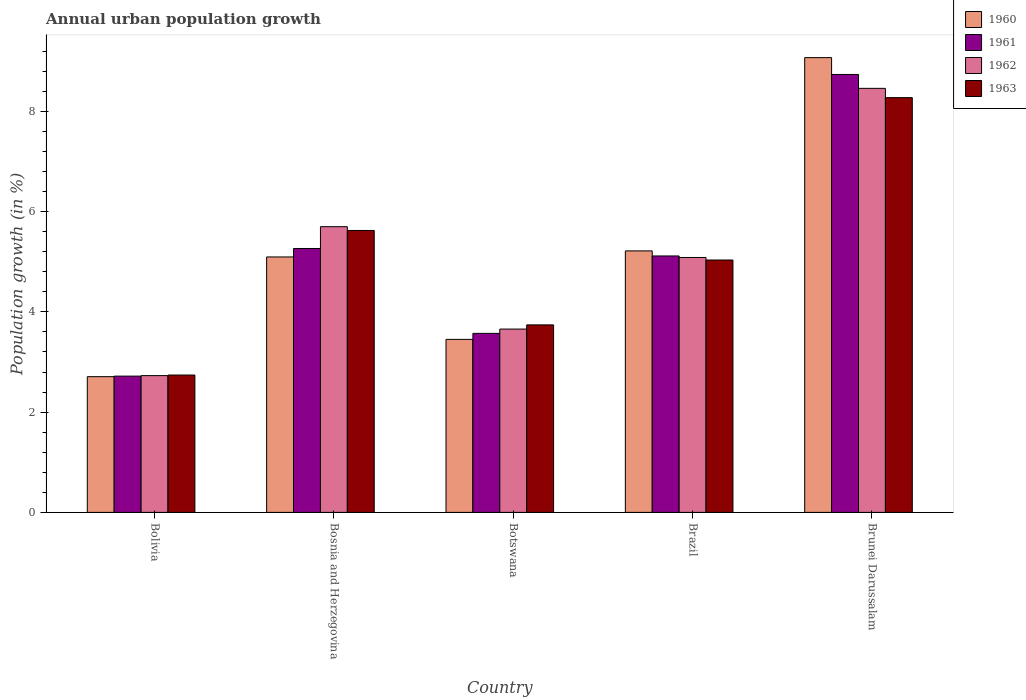How many different coloured bars are there?
Provide a succinct answer. 4. Are the number of bars on each tick of the X-axis equal?
Give a very brief answer. Yes. How many bars are there on the 1st tick from the left?
Your answer should be compact. 4. What is the label of the 2nd group of bars from the left?
Ensure brevity in your answer.  Bosnia and Herzegovina. What is the percentage of urban population growth in 1963 in Bolivia?
Ensure brevity in your answer.  2.74. Across all countries, what is the maximum percentage of urban population growth in 1963?
Your answer should be compact. 8.27. Across all countries, what is the minimum percentage of urban population growth in 1961?
Offer a terse response. 2.72. In which country was the percentage of urban population growth in 1961 maximum?
Provide a succinct answer. Brunei Darussalam. In which country was the percentage of urban population growth in 1963 minimum?
Your answer should be very brief. Bolivia. What is the total percentage of urban population growth in 1960 in the graph?
Make the answer very short. 25.54. What is the difference between the percentage of urban population growth in 1962 in Brazil and that in Brunei Darussalam?
Ensure brevity in your answer.  -3.37. What is the difference between the percentage of urban population growth in 1963 in Brunei Darussalam and the percentage of urban population growth in 1961 in Brazil?
Provide a short and direct response. 3.16. What is the average percentage of urban population growth in 1961 per country?
Your answer should be very brief. 5.08. What is the difference between the percentage of urban population growth of/in 1961 and percentage of urban population growth of/in 1960 in Brunei Darussalam?
Provide a succinct answer. -0.34. In how many countries, is the percentage of urban population growth in 1961 greater than 4.8 %?
Offer a terse response. 3. What is the ratio of the percentage of urban population growth in 1960 in Bosnia and Herzegovina to that in Brazil?
Your response must be concise. 0.98. Is the percentage of urban population growth in 1960 in Bosnia and Herzegovina less than that in Brunei Darussalam?
Give a very brief answer. Yes. What is the difference between the highest and the second highest percentage of urban population growth in 1960?
Offer a terse response. 3.98. What is the difference between the highest and the lowest percentage of urban population growth in 1962?
Give a very brief answer. 5.73. What does the 3rd bar from the left in Botswana represents?
Keep it short and to the point. 1962. What does the 2nd bar from the right in Botswana represents?
Your response must be concise. 1962. How many bars are there?
Your answer should be very brief. 20. How many countries are there in the graph?
Your answer should be compact. 5. Are the values on the major ticks of Y-axis written in scientific E-notation?
Provide a succinct answer. No. How are the legend labels stacked?
Offer a very short reply. Vertical. What is the title of the graph?
Give a very brief answer. Annual urban population growth. What is the label or title of the Y-axis?
Make the answer very short. Population growth (in %). What is the Population growth (in %) in 1960 in Bolivia?
Keep it short and to the point. 2.71. What is the Population growth (in %) in 1961 in Bolivia?
Offer a very short reply. 2.72. What is the Population growth (in %) in 1962 in Bolivia?
Make the answer very short. 2.73. What is the Population growth (in %) of 1963 in Bolivia?
Offer a terse response. 2.74. What is the Population growth (in %) of 1960 in Bosnia and Herzegovina?
Give a very brief answer. 5.1. What is the Population growth (in %) of 1961 in Bosnia and Herzegovina?
Keep it short and to the point. 5.26. What is the Population growth (in %) in 1962 in Bosnia and Herzegovina?
Your answer should be very brief. 5.7. What is the Population growth (in %) in 1963 in Bosnia and Herzegovina?
Make the answer very short. 5.62. What is the Population growth (in %) in 1960 in Botswana?
Make the answer very short. 3.45. What is the Population growth (in %) in 1961 in Botswana?
Ensure brevity in your answer.  3.57. What is the Population growth (in %) in 1962 in Botswana?
Your response must be concise. 3.66. What is the Population growth (in %) in 1963 in Botswana?
Your answer should be very brief. 3.74. What is the Population growth (in %) of 1960 in Brazil?
Provide a succinct answer. 5.22. What is the Population growth (in %) of 1961 in Brazil?
Offer a terse response. 5.12. What is the Population growth (in %) of 1962 in Brazil?
Offer a terse response. 5.09. What is the Population growth (in %) of 1963 in Brazil?
Your response must be concise. 5.03. What is the Population growth (in %) in 1960 in Brunei Darussalam?
Provide a succinct answer. 9.07. What is the Population growth (in %) in 1961 in Brunei Darussalam?
Keep it short and to the point. 8.74. What is the Population growth (in %) of 1962 in Brunei Darussalam?
Give a very brief answer. 8.46. What is the Population growth (in %) of 1963 in Brunei Darussalam?
Your response must be concise. 8.27. Across all countries, what is the maximum Population growth (in %) of 1960?
Provide a short and direct response. 9.07. Across all countries, what is the maximum Population growth (in %) of 1961?
Keep it short and to the point. 8.74. Across all countries, what is the maximum Population growth (in %) in 1962?
Offer a terse response. 8.46. Across all countries, what is the maximum Population growth (in %) of 1963?
Your answer should be compact. 8.27. Across all countries, what is the minimum Population growth (in %) in 1960?
Offer a terse response. 2.71. Across all countries, what is the minimum Population growth (in %) in 1961?
Offer a terse response. 2.72. Across all countries, what is the minimum Population growth (in %) of 1962?
Offer a very short reply. 2.73. Across all countries, what is the minimum Population growth (in %) of 1963?
Your response must be concise. 2.74. What is the total Population growth (in %) of 1960 in the graph?
Keep it short and to the point. 25.54. What is the total Population growth (in %) of 1961 in the graph?
Make the answer very short. 25.41. What is the total Population growth (in %) in 1962 in the graph?
Provide a succinct answer. 25.63. What is the total Population growth (in %) of 1963 in the graph?
Your answer should be very brief. 25.41. What is the difference between the Population growth (in %) of 1960 in Bolivia and that in Bosnia and Herzegovina?
Your answer should be compact. -2.39. What is the difference between the Population growth (in %) in 1961 in Bolivia and that in Bosnia and Herzegovina?
Provide a succinct answer. -2.55. What is the difference between the Population growth (in %) in 1962 in Bolivia and that in Bosnia and Herzegovina?
Give a very brief answer. -2.97. What is the difference between the Population growth (in %) of 1963 in Bolivia and that in Bosnia and Herzegovina?
Your answer should be compact. -2.88. What is the difference between the Population growth (in %) of 1960 in Bolivia and that in Botswana?
Your response must be concise. -0.74. What is the difference between the Population growth (in %) of 1961 in Bolivia and that in Botswana?
Keep it short and to the point. -0.85. What is the difference between the Population growth (in %) of 1962 in Bolivia and that in Botswana?
Provide a short and direct response. -0.93. What is the difference between the Population growth (in %) in 1963 in Bolivia and that in Botswana?
Provide a short and direct response. -1. What is the difference between the Population growth (in %) of 1960 in Bolivia and that in Brazil?
Give a very brief answer. -2.51. What is the difference between the Population growth (in %) in 1961 in Bolivia and that in Brazil?
Keep it short and to the point. -2.4. What is the difference between the Population growth (in %) in 1962 in Bolivia and that in Brazil?
Offer a very short reply. -2.36. What is the difference between the Population growth (in %) of 1963 in Bolivia and that in Brazil?
Provide a succinct answer. -2.29. What is the difference between the Population growth (in %) of 1960 in Bolivia and that in Brunei Darussalam?
Your answer should be compact. -6.36. What is the difference between the Population growth (in %) in 1961 in Bolivia and that in Brunei Darussalam?
Ensure brevity in your answer.  -6.02. What is the difference between the Population growth (in %) of 1962 in Bolivia and that in Brunei Darussalam?
Ensure brevity in your answer.  -5.73. What is the difference between the Population growth (in %) of 1963 in Bolivia and that in Brunei Darussalam?
Ensure brevity in your answer.  -5.53. What is the difference between the Population growth (in %) of 1960 in Bosnia and Herzegovina and that in Botswana?
Your response must be concise. 1.64. What is the difference between the Population growth (in %) in 1961 in Bosnia and Herzegovina and that in Botswana?
Provide a succinct answer. 1.69. What is the difference between the Population growth (in %) of 1962 in Bosnia and Herzegovina and that in Botswana?
Your response must be concise. 2.04. What is the difference between the Population growth (in %) of 1963 in Bosnia and Herzegovina and that in Botswana?
Provide a short and direct response. 1.88. What is the difference between the Population growth (in %) of 1960 in Bosnia and Herzegovina and that in Brazil?
Make the answer very short. -0.12. What is the difference between the Population growth (in %) in 1961 in Bosnia and Herzegovina and that in Brazil?
Make the answer very short. 0.15. What is the difference between the Population growth (in %) of 1962 in Bosnia and Herzegovina and that in Brazil?
Ensure brevity in your answer.  0.61. What is the difference between the Population growth (in %) in 1963 in Bosnia and Herzegovina and that in Brazil?
Offer a very short reply. 0.59. What is the difference between the Population growth (in %) of 1960 in Bosnia and Herzegovina and that in Brunei Darussalam?
Provide a short and direct response. -3.98. What is the difference between the Population growth (in %) of 1961 in Bosnia and Herzegovina and that in Brunei Darussalam?
Offer a terse response. -3.47. What is the difference between the Population growth (in %) of 1962 in Bosnia and Herzegovina and that in Brunei Darussalam?
Ensure brevity in your answer.  -2.76. What is the difference between the Population growth (in %) in 1963 in Bosnia and Herzegovina and that in Brunei Darussalam?
Your answer should be compact. -2.65. What is the difference between the Population growth (in %) in 1960 in Botswana and that in Brazil?
Provide a short and direct response. -1.76. What is the difference between the Population growth (in %) in 1961 in Botswana and that in Brazil?
Give a very brief answer. -1.54. What is the difference between the Population growth (in %) in 1962 in Botswana and that in Brazil?
Your response must be concise. -1.43. What is the difference between the Population growth (in %) of 1963 in Botswana and that in Brazil?
Your answer should be very brief. -1.29. What is the difference between the Population growth (in %) of 1960 in Botswana and that in Brunei Darussalam?
Your answer should be compact. -5.62. What is the difference between the Population growth (in %) of 1961 in Botswana and that in Brunei Darussalam?
Your answer should be very brief. -5.16. What is the difference between the Population growth (in %) in 1962 in Botswana and that in Brunei Darussalam?
Provide a short and direct response. -4.8. What is the difference between the Population growth (in %) of 1963 in Botswana and that in Brunei Darussalam?
Offer a very short reply. -4.53. What is the difference between the Population growth (in %) in 1960 in Brazil and that in Brunei Darussalam?
Make the answer very short. -3.86. What is the difference between the Population growth (in %) in 1961 in Brazil and that in Brunei Darussalam?
Provide a succinct answer. -3.62. What is the difference between the Population growth (in %) of 1962 in Brazil and that in Brunei Darussalam?
Offer a terse response. -3.37. What is the difference between the Population growth (in %) of 1963 in Brazil and that in Brunei Darussalam?
Make the answer very short. -3.24. What is the difference between the Population growth (in %) of 1960 in Bolivia and the Population growth (in %) of 1961 in Bosnia and Herzegovina?
Ensure brevity in your answer.  -2.56. What is the difference between the Population growth (in %) of 1960 in Bolivia and the Population growth (in %) of 1962 in Bosnia and Herzegovina?
Your answer should be compact. -2.99. What is the difference between the Population growth (in %) in 1960 in Bolivia and the Population growth (in %) in 1963 in Bosnia and Herzegovina?
Your answer should be compact. -2.92. What is the difference between the Population growth (in %) in 1961 in Bolivia and the Population growth (in %) in 1962 in Bosnia and Herzegovina?
Offer a terse response. -2.98. What is the difference between the Population growth (in %) in 1961 in Bolivia and the Population growth (in %) in 1963 in Bosnia and Herzegovina?
Your answer should be compact. -2.91. What is the difference between the Population growth (in %) in 1962 in Bolivia and the Population growth (in %) in 1963 in Bosnia and Herzegovina?
Ensure brevity in your answer.  -2.9. What is the difference between the Population growth (in %) in 1960 in Bolivia and the Population growth (in %) in 1961 in Botswana?
Make the answer very short. -0.86. What is the difference between the Population growth (in %) of 1960 in Bolivia and the Population growth (in %) of 1962 in Botswana?
Provide a succinct answer. -0.95. What is the difference between the Population growth (in %) of 1960 in Bolivia and the Population growth (in %) of 1963 in Botswana?
Your response must be concise. -1.03. What is the difference between the Population growth (in %) in 1961 in Bolivia and the Population growth (in %) in 1962 in Botswana?
Make the answer very short. -0.94. What is the difference between the Population growth (in %) in 1961 in Bolivia and the Population growth (in %) in 1963 in Botswana?
Provide a short and direct response. -1.02. What is the difference between the Population growth (in %) of 1962 in Bolivia and the Population growth (in %) of 1963 in Botswana?
Provide a short and direct response. -1.01. What is the difference between the Population growth (in %) in 1960 in Bolivia and the Population growth (in %) in 1961 in Brazil?
Your response must be concise. -2.41. What is the difference between the Population growth (in %) in 1960 in Bolivia and the Population growth (in %) in 1962 in Brazil?
Give a very brief answer. -2.38. What is the difference between the Population growth (in %) in 1960 in Bolivia and the Population growth (in %) in 1963 in Brazil?
Your answer should be compact. -2.33. What is the difference between the Population growth (in %) of 1961 in Bolivia and the Population growth (in %) of 1962 in Brazil?
Provide a succinct answer. -2.37. What is the difference between the Population growth (in %) of 1961 in Bolivia and the Population growth (in %) of 1963 in Brazil?
Provide a short and direct response. -2.32. What is the difference between the Population growth (in %) in 1962 in Bolivia and the Population growth (in %) in 1963 in Brazil?
Provide a short and direct response. -2.31. What is the difference between the Population growth (in %) in 1960 in Bolivia and the Population growth (in %) in 1961 in Brunei Darussalam?
Your answer should be compact. -6.03. What is the difference between the Population growth (in %) in 1960 in Bolivia and the Population growth (in %) in 1962 in Brunei Darussalam?
Make the answer very short. -5.75. What is the difference between the Population growth (in %) of 1960 in Bolivia and the Population growth (in %) of 1963 in Brunei Darussalam?
Your answer should be very brief. -5.57. What is the difference between the Population growth (in %) of 1961 in Bolivia and the Population growth (in %) of 1962 in Brunei Darussalam?
Ensure brevity in your answer.  -5.74. What is the difference between the Population growth (in %) of 1961 in Bolivia and the Population growth (in %) of 1963 in Brunei Darussalam?
Your response must be concise. -5.56. What is the difference between the Population growth (in %) of 1962 in Bolivia and the Population growth (in %) of 1963 in Brunei Darussalam?
Your response must be concise. -5.55. What is the difference between the Population growth (in %) of 1960 in Bosnia and Herzegovina and the Population growth (in %) of 1961 in Botswana?
Ensure brevity in your answer.  1.52. What is the difference between the Population growth (in %) in 1960 in Bosnia and Herzegovina and the Population growth (in %) in 1962 in Botswana?
Your answer should be very brief. 1.44. What is the difference between the Population growth (in %) of 1960 in Bosnia and Herzegovina and the Population growth (in %) of 1963 in Botswana?
Offer a terse response. 1.36. What is the difference between the Population growth (in %) of 1961 in Bosnia and Herzegovina and the Population growth (in %) of 1962 in Botswana?
Your response must be concise. 1.61. What is the difference between the Population growth (in %) of 1961 in Bosnia and Herzegovina and the Population growth (in %) of 1963 in Botswana?
Provide a short and direct response. 1.52. What is the difference between the Population growth (in %) in 1962 in Bosnia and Herzegovina and the Population growth (in %) in 1963 in Botswana?
Offer a very short reply. 1.96. What is the difference between the Population growth (in %) of 1960 in Bosnia and Herzegovina and the Population growth (in %) of 1961 in Brazil?
Offer a terse response. -0.02. What is the difference between the Population growth (in %) in 1960 in Bosnia and Herzegovina and the Population growth (in %) in 1962 in Brazil?
Your response must be concise. 0.01. What is the difference between the Population growth (in %) of 1960 in Bosnia and Herzegovina and the Population growth (in %) of 1963 in Brazil?
Give a very brief answer. 0.06. What is the difference between the Population growth (in %) of 1961 in Bosnia and Herzegovina and the Population growth (in %) of 1962 in Brazil?
Keep it short and to the point. 0.18. What is the difference between the Population growth (in %) in 1961 in Bosnia and Herzegovina and the Population growth (in %) in 1963 in Brazil?
Offer a terse response. 0.23. What is the difference between the Population growth (in %) in 1962 in Bosnia and Herzegovina and the Population growth (in %) in 1963 in Brazil?
Offer a very short reply. 0.66. What is the difference between the Population growth (in %) in 1960 in Bosnia and Herzegovina and the Population growth (in %) in 1961 in Brunei Darussalam?
Your response must be concise. -3.64. What is the difference between the Population growth (in %) of 1960 in Bosnia and Herzegovina and the Population growth (in %) of 1962 in Brunei Darussalam?
Your answer should be compact. -3.36. What is the difference between the Population growth (in %) in 1960 in Bosnia and Herzegovina and the Population growth (in %) in 1963 in Brunei Darussalam?
Offer a terse response. -3.18. What is the difference between the Population growth (in %) in 1961 in Bosnia and Herzegovina and the Population growth (in %) in 1962 in Brunei Darussalam?
Offer a terse response. -3.19. What is the difference between the Population growth (in %) in 1961 in Bosnia and Herzegovina and the Population growth (in %) in 1963 in Brunei Darussalam?
Ensure brevity in your answer.  -3.01. What is the difference between the Population growth (in %) of 1962 in Bosnia and Herzegovina and the Population growth (in %) of 1963 in Brunei Darussalam?
Offer a terse response. -2.57. What is the difference between the Population growth (in %) in 1960 in Botswana and the Population growth (in %) in 1961 in Brazil?
Ensure brevity in your answer.  -1.66. What is the difference between the Population growth (in %) in 1960 in Botswana and the Population growth (in %) in 1962 in Brazil?
Your answer should be very brief. -1.63. What is the difference between the Population growth (in %) in 1960 in Botswana and the Population growth (in %) in 1963 in Brazil?
Keep it short and to the point. -1.58. What is the difference between the Population growth (in %) in 1961 in Botswana and the Population growth (in %) in 1962 in Brazil?
Provide a short and direct response. -1.51. What is the difference between the Population growth (in %) of 1961 in Botswana and the Population growth (in %) of 1963 in Brazil?
Ensure brevity in your answer.  -1.46. What is the difference between the Population growth (in %) of 1962 in Botswana and the Population growth (in %) of 1963 in Brazil?
Provide a short and direct response. -1.38. What is the difference between the Population growth (in %) of 1960 in Botswana and the Population growth (in %) of 1961 in Brunei Darussalam?
Keep it short and to the point. -5.28. What is the difference between the Population growth (in %) of 1960 in Botswana and the Population growth (in %) of 1962 in Brunei Darussalam?
Provide a short and direct response. -5.01. What is the difference between the Population growth (in %) in 1960 in Botswana and the Population growth (in %) in 1963 in Brunei Darussalam?
Provide a short and direct response. -4.82. What is the difference between the Population growth (in %) of 1961 in Botswana and the Population growth (in %) of 1962 in Brunei Darussalam?
Make the answer very short. -4.89. What is the difference between the Population growth (in %) of 1961 in Botswana and the Population growth (in %) of 1963 in Brunei Darussalam?
Provide a succinct answer. -4.7. What is the difference between the Population growth (in %) in 1962 in Botswana and the Population growth (in %) in 1963 in Brunei Darussalam?
Your answer should be very brief. -4.62. What is the difference between the Population growth (in %) of 1960 in Brazil and the Population growth (in %) of 1961 in Brunei Darussalam?
Your answer should be very brief. -3.52. What is the difference between the Population growth (in %) of 1960 in Brazil and the Population growth (in %) of 1962 in Brunei Darussalam?
Provide a succinct answer. -3.24. What is the difference between the Population growth (in %) in 1960 in Brazil and the Population growth (in %) in 1963 in Brunei Darussalam?
Your answer should be very brief. -3.06. What is the difference between the Population growth (in %) in 1961 in Brazil and the Population growth (in %) in 1962 in Brunei Darussalam?
Your answer should be very brief. -3.34. What is the difference between the Population growth (in %) of 1961 in Brazil and the Population growth (in %) of 1963 in Brunei Darussalam?
Your answer should be very brief. -3.16. What is the difference between the Population growth (in %) of 1962 in Brazil and the Population growth (in %) of 1963 in Brunei Darussalam?
Your response must be concise. -3.19. What is the average Population growth (in %) in 1960 per country?
Provide a short and direct response. 5.11. What is the average Population growth (in %) in 1961 per country?
Offer a very short reply. 5.08. What is the average Population growth (in %) of 1962 per country?
Your response must be concise. 5.13. What is the average Population growth (in %) in 1963 per country?
Your answer should be very brief. 5.08. What is the difference between the Population growth (in %) of 1960 and Population growth (in %) of 1961 in Bolivia?
Give a very brief answer. -0.01. What is the difference between the Population growth (in %) of 1960 and Population growth (in %) of 1962 in Bolivia?
Give a very brief answer. -0.02. What is the difference between the Population growth (in %) of 1960 and Population growth (in %) of 1963 in Bolivia?
Offer a terse response. -0.03. What is the difference between the Population growth (in %) of 1961 and Population growth (in %) of 1962 in Bolivia?
Provide a succinct answer. -0.01. What is the difference between the Population growth (in %) in 1961 and Population growth (in %) in 1963 in Bolivia?
Your response must be concise. -0.02. What is the difference between the Population growth (in %) of 1962 and Population growth (in %) of 1963 in Bolivia?
Your response must be concise. -0.01. What is the difference between the Population growth (in %) of 1960 and Population growth (in %) of 1961 in Bosnia and Herzegovina?
Offer a terse response. -0.17. What is the difference between the Population growth (in %) in 1960 and Population growth (in %) in 1962 in Bosnia and Herzegovina?
Provide a succinct answer. -0.6. What is the difference between the Population growth (in %) in 1960 and Population growth (in %) in 1963 in Bosnia and Herzegovina?
Make the answer very short. -0.53. What is the difference between the Population growth (in %) of 1961 and Population growth (in %) of 1962 in Bosnia and Herzegovina?
Provide a short and direct response. -0.43. What is the difference between the Population growth (in %) of 1961 and Population growth (in %) of 1963 in Bosnia and Herzegovina?
Provide a short and direct response. -0.36. What is the difference between the Population growth (in %) of 1962 and Population growth (in %) of 1963 in Bosnia and Herzegovina?
Give a very brief answer. 0.08. What is the difference between the Population growth (in %) of 1960 and Population growth (in %) of 1961 in Botswana?
Make the answer very short. -0.12. What is the difference between the Population growth (in %) in 1960 and Population growth (in %) in 1962 in Botswana?
Your answer should be very brief. -0.21. What is the difference between the Population growth (in %) of 1960 and Population growth (in %) of 1963 in Botswana?
Your answer should be compact. -0.29. What is the difference between the Population growth (in %) in 1961 and Population growth (in %) in 1962 in Botswana?
Keep it short and to the point. -0.09. What is the difference between the Population growth (in %) in 1961 and Population growth (in %) in 1963 in Botswana?
Keep it short and to the point. -0.17. What is the difference between the Population growth (in %) in 1962 and Population growth (in %) in 1963 in Botswana?
Give a very brief answer. -0.08. What is the difference between the Population growth (in %) of 1960 and Population growth (in %) of 1961 in Brazil?
Provide a short and direct response. 0.1. What is the difference between the Population growth (in %) in 1960 and Population growth (in %) in 1962 in Brazil?
Provide a succinct answer. 0.13. What is the difference between the Population growth (in %) in 1960 and Population growth (in %) in 1963 in Brazil?
Provide a short and direct response. 0.18. What is the difference between the Population growth (in %) in 1961 and Population growth (in %) in 1962 in Brazil?
Provide a short and direct response. 0.03. What is the difference between the Population growth (in %) in 1961 and Population growth (in %) in 1963 in Brazil?
Your answer should be very brief. 0.08. What is the difference between the Population growth (in %) of 1962 and Population growth (in %) of 1963 in Brazil?
Give a very brief answer. 0.05. What is the difference between the Population growth (in %) of 1960 and Population growth (in %) of 1961 in Brunei Darussalam?
Provide a succinct answer. 0.34. What is the difference between the Population growth (in %) of 1960 and Population growth (in %) of 1962 in Brunei Darussalam?
Offer a terse response. 0.61. What is the difference between the Population growth (in %) in 1960 and Population growth (in %) in 1963 in Brunei Darussalam?
Offer a very short reply. 0.8. What is the difference between the Population growth (in %) in 1961 and Population growth (in %) in 1962 in Brunei Darussalam?
Provide a succinct answer. 0.28. What is the difference between the Population growth (in %) in 1961 and Population growth (in %) in 1963 in Brunei Darussalam?
Keep it short and to the point. 0.46. What is the difference between the Population growth (in %) in 1962 and Population growth (in %) in 1963 in Brunei Darussalam?
Provide a short and direct response. 0.19. What is the ratio of the Population growth (in %) in 1960 in Bolivia to that in Bosnia and Herzegovina?
Provide a succinct answer. 0.53. What is the ratio of the Population growth (in %) in 1961 in Bolivia to that in Bosnia and Herzegovina?
Offer a very short reply. 0.52. What is the ratio of the Population growth (in %) in 1962 in Bolivia to that in Bosnia and Herzegovina?
Offer a terse response. 0.48. What is the ratio of the Population growth (in %) in 1963 in Bolivia to that in Bosnia and Herzegovina?
Provide a short and direct response. 0.49. What is the ratio of the Population growth (in %) of 1960 in Bolivia to that in Botswana?
Give a very brief answer. 0.78. What is the ratio of the Population growth (in %) in 1961 in Bolivia to that in Botswana?
Offer a terse response. 0.76. What is the ratio of the Population growth (in %) of 1962 in Bolivia to that in Botswana?
Your answer should be compact. 0.75. What is the ratio of the Population growth (in %) of 1963 in Bolivia to that in Botswana?
Offer a terse response. 0.73. What is the ratio of the Population growth (in %) of 1960 in Bolivia to that in Brazil?
Give a very brief answer. 0.52. What is the ratio of the Population growth (in %) in 1961 in Bolivia to that in Brazil?
Offer a very short reply. 0.53. What is the ratio of the Population growth (in %) of 1962 in Bolivia to that in Brazil?
Make the answer very short. 0.54. What is the ratio of the Population growth (in %) in 1963 in Bolivia to that in Brazil?
Offer a terse response. 0.54. What is the ratio of the Population growth (in %) in 1960 in Bolivia to that in Brunei Darussalam?
Provide a short and direct response. 0.3. What is the ratio of the Population growth (in %) in 1961 in Bolivia to that in Brunei Darussalam?
Keep it short and to the point. 0.31. What is the ratio of the Population growth (in %) of 1962 in Bolivia to that in Brunei Darussalam?
Ensure brevity in your answer.  0.32. What is the ratio of the Population growth (in %) in 1963 in Bolivia to that in Brunei Darussalam?
Make the answer very short. 0.33. What is the ratio of the Population growth (in %) of 1960 in Bosnia and Herzegovina to that in Botswana?
Keep it short and to the point. 1.48. What is the ratio of the Population growth (in %) in 1961 in Bosnia and Herzegovina to that in Botswana?
Make the answer very short. 1.47. What is the ratio of the Population growth (in %) in 1962 in Bosnia and Herzegovina to that in Botswana?
Offer a very short reply. 1.56. What is the ratio of the Population growth (in %) in 1963 in Bosnia and Herzegovina to that in Botswana?
Your response must be concise. 1.5. What is the ratio of the Population growth (in %) of 1960 in Bosnia and Herzegovina to that in Brazil?
Ensure brevity in your answer.  0.98. What is the ratio of the Population growth (in %) of 1961 in Bosnia and Herzegovina to that in Brazil?
Keep it short and to the point. 1.03. What is the ratio of the Population growth (in %) in 1962 in Bosnia and Herzegovina to that in Brazil?
Your answer should be very brief. 1.12. What is the ratio of the Population growth (in %) in 1963 in Bosnia and Herzegovina to that in Brazil?
Your answer should be very brief. 1.12. What is the ratio of the Population growth (in %) of 1960 in Bosnia and Herzegovina to that in Brunei Darussalam?
Offer a very short reply. 0.56. What is the ratio of the Population growth (in %) in 1961 in Bosnia and Herzegovina to that in Brunei Darussalam?
Offer a very short reply. 0.6. What is the ratio of the Population growth (in %) in 1962 in Bosnia and Herzegovina to that in Brunei Darussalam?
Offer a terse response. 0.67. What is the ratio of the Population growth (in %) in 1963 in Bosnia and Herzegovina to that in Brunei Darussalam?
Your answer should be compact. 0.68. What is the ratio of the Population growth (in %) in 1960 in Botswana to that in Brazil?
Provide a short and direct response. 0.66. What is the ratio of the Population growth (in %) in 1961 in Botswana to that in Brazil?
Your answer should be compact. 0.7. What is the ratio of the Population growth (in %) of 1962 in Botswana to that in Brazil?
Ensure brevity in your answer.  0.72. What is the ratio of the Population growth (in %) of 1963 in Botswana to that in Brazil?
Offer a terse response. 0.74. What is the ratio of the Population growth (in %) in 1960 in Botswana to that in Brunei Darussalam?
Your answer should be compact. 0.38. What is the ratio of the Population growth (in %) of 1961 in Botswana to that in Brunei Darussalam?
Offer a terse response. 0.41. What is the ratio of the Population growth (in %) in 1962 in Botswana to that in Brunei Darussalam?
Provide a short and direct response. 0.43. What is the ratio of the Population growth (in %) of 1963 in Botswana to that in Brunei Darussalam?
Your answer should be compact. 0.45. What is the ratio of the Population growth (in %) in 1960 in Brazil to that in Brunei Darussalam?
Your response must be concise. 0.57. What is the ratio of the Population growth (in %) of 1961 in Brazil to that in Brunei Darussalam?
Give a very brief answer. 0.59. What is the ratio of the Population growth (in %) in 1962 in Brazil to that in Brunei Darussalam?
Offer a terse response. 0.6. What is the ratio of the Population growth (in %) of 1963 in Brazil to that in Brunei Darussalam?
Make the answer very short. 0.61. What is the difference between the highest and the second highest Population growth (in %) in 1960?
Give a very brief answer. 3.86. What is the difference between the highest and the second highest Population growth (in %) of 1961?
Your response must be concise. 3.47. What is the difference between the highest and the second highest Population growth (in %) of 1962?
Your answer should be compact. 2.76. What is the difference between the highest and the second highest Population growth (in %) in 1963?
Offer a terse response. 2.65. What is the difference between the highest and the lowest Population growth (in %) in 1960?
Keep it short and to the point. 6.36. What is the difference between the highest and the lowest Population growth (in %) in 1961?
Offer a very short reply. 6.02. What is the difference between the highest and the lowest Population growth (in %) in 1962?
Make the answer very short. 5.73. What is the difference between the highest and the lowest Population growth (in %) of 1963?
Give a very brief answer. 5.53. 